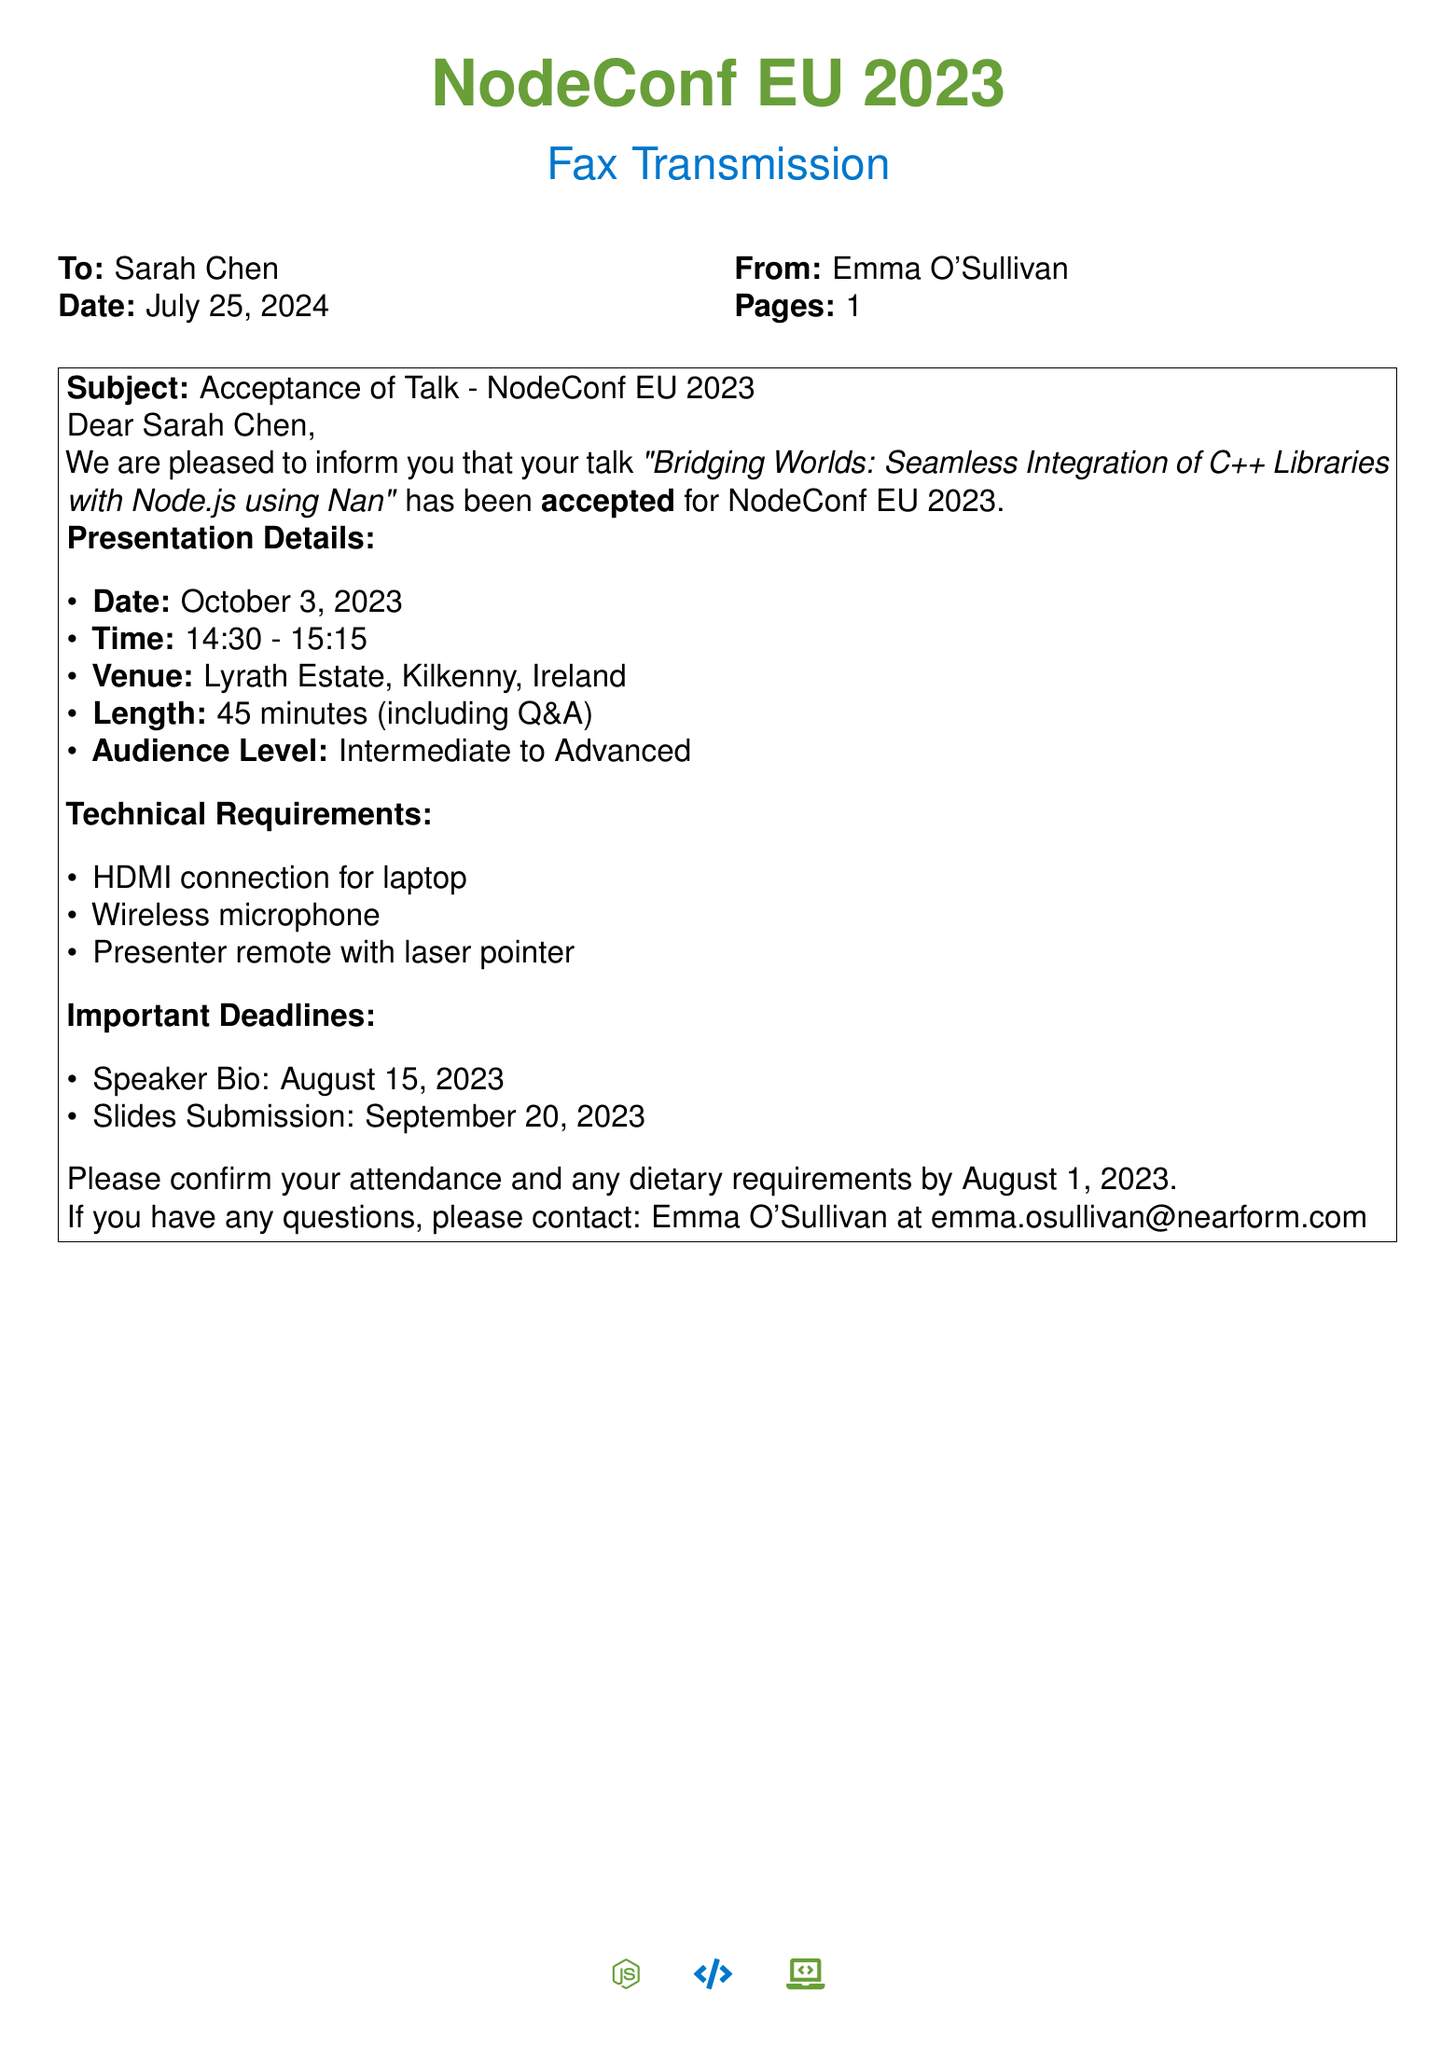What is the title of the accepted talk? The title of the accepted talk is mentioned in the subject line of the fax.
Answer: Bridging Worlds: Seamless Integration of C++ Libraries with Node.js using Nan What is the date of the presentation? The date of the presentation is specified under the presentation details section.
Answer: October 3, 2023 What time does the presentation start? The start time is listed in the presentation details of the fax.
Answer: 14:30 How long is the presentation scheduled to last? The length of the presentation, including Q&A, is detailed in the presentation section.
Answer: 45 minutes What are the technical requirements listed for the presentation? The technical requirements can be found in the respective section of the document.
Answer: HDMI connection for laptop, Wireless microphone, Presenter remote with laser pointer When is the deadline for slides submission? The deadline for slides submission is specified in the important deadlines section.
Answer: September 20, 2023 Who should be contacted for questions regarding the fax? The contact information is provided at the end of the document.
Answer: Emma O'Sullivan What is the audience level for the talk? The audience level is mentioned in the presentation details section of the fax.
Answer: Intermediate to Advanced 